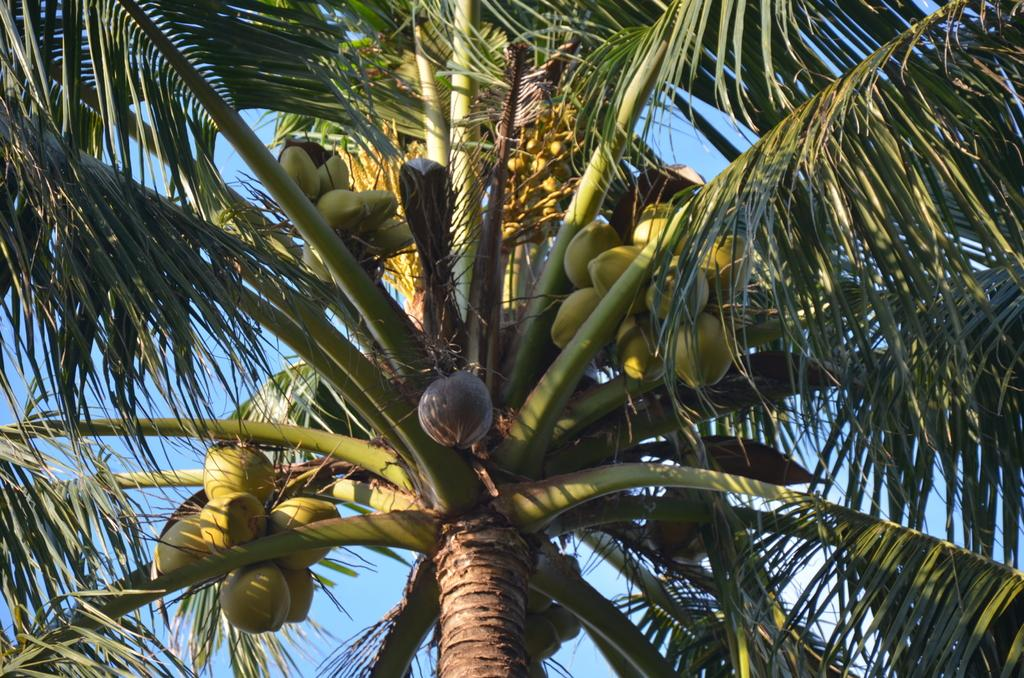What type of fruit can be seen on the tree in the image? There are coconuts on a tree in the image. What color is the sky in the image? The sky is blue in the image. What type of mine is visible in the image? There is no mine present in the image; it features coconuts on a tree and a blue sky. What type of linen can be seen draped over the tree in the image? There is no linen present in the image; it only features coconuts on a tree and a blue sky. 